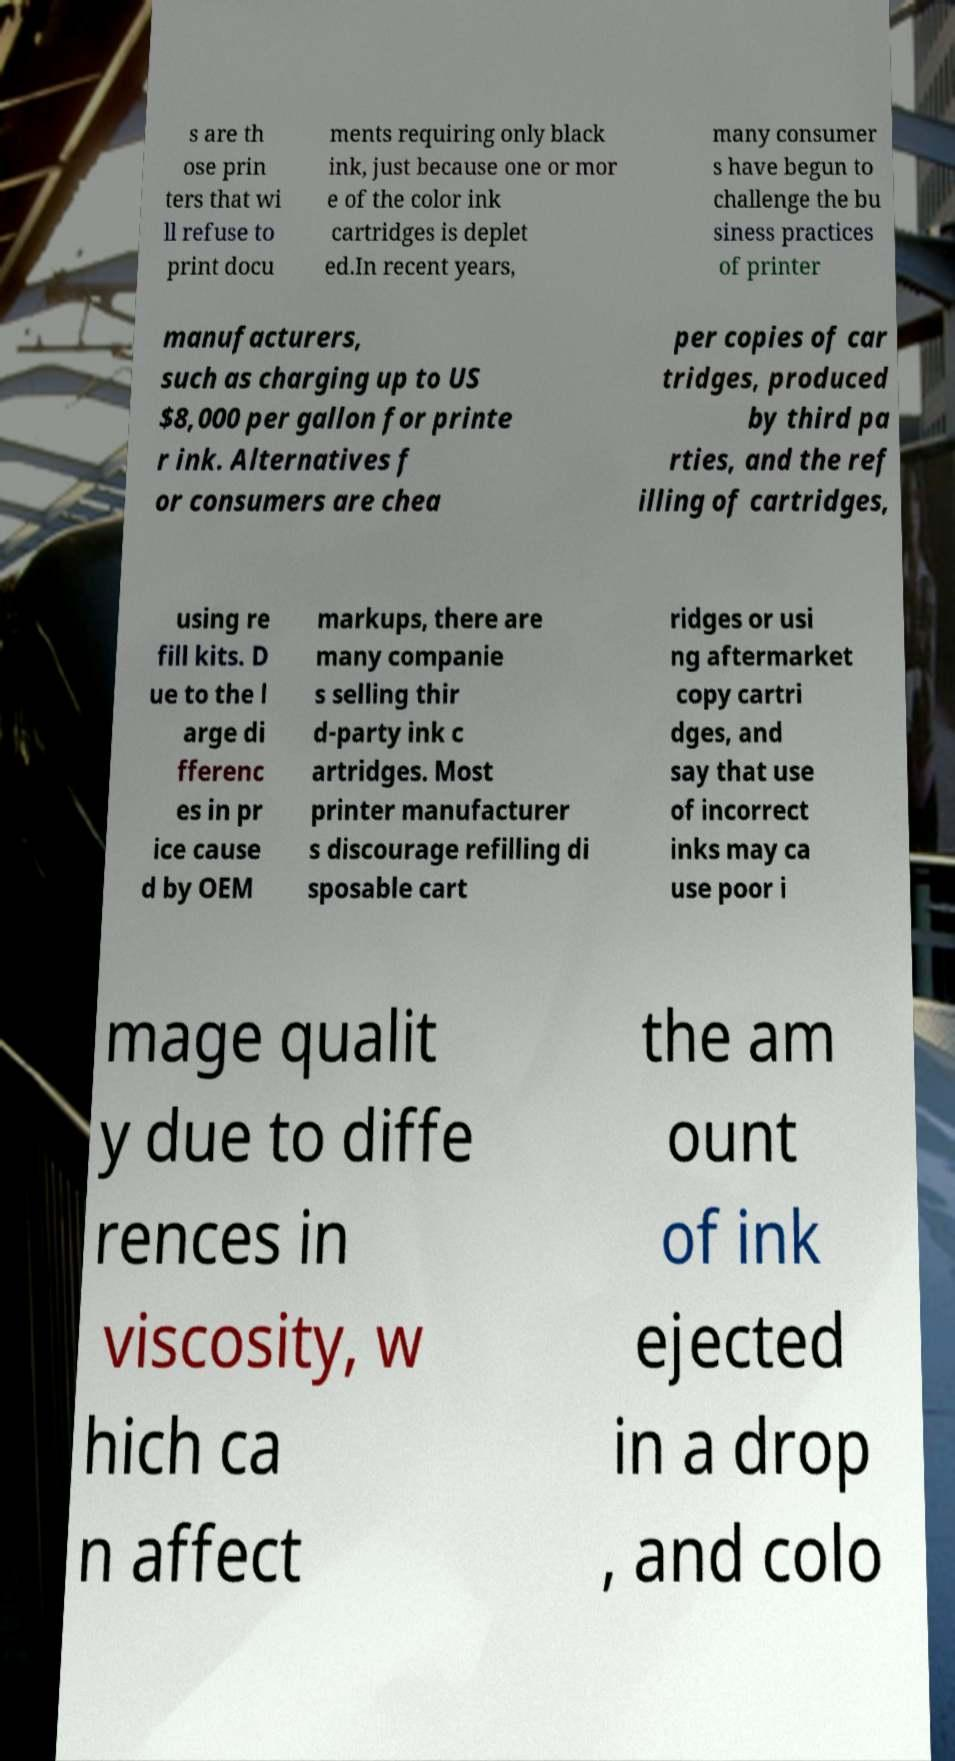What messages or text are displayed in this image? I need them in a readable, typed format. s are th ose prin ters that wi ll refuse to print docu ments requiring only black ink, just because one or mor e of the color ink cartridges is deplet ed.In recent years, many consumer s have begun to challenge the bu siness practices of printer manufacturers, such as charging up to US $8,000 per gallon for printe r ink. Alternatives f or consumers are chea per copies of car tridges, produced by third pa rties, and the ref illing of cartridges, using re fill kits. D ue to the l arge di fferenc es in pr ice cause d by OEM markups, there are many companie s selling thir d-party ink c artridges. Most printer manufacturer s discourage refilling di sposable cart ridges or usi ng aftermarket copy cartri dges, and say that use of incorrect inks may ca use poor i mage qualit y due to diffe rences in viscosity, w hich ca n affect the am ount of ink ejected in a drop , and colo 